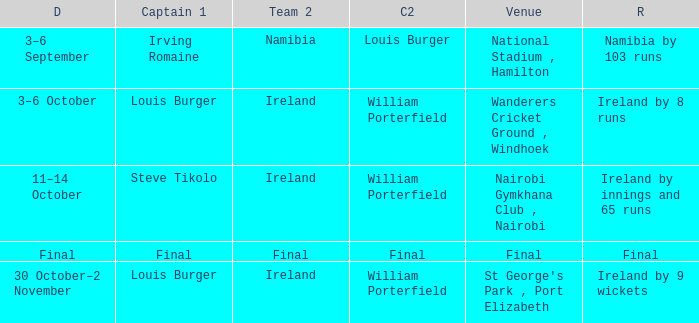Which Result has a Captain 2 of louis burger? Namibia by 103 runs. Can you parse all the data within this table? {'header': ['D', 'Captain 1', 'Team 2', 'C2', 'Venue', 'R'], 'rows': [['3–6 September', 'Irving Romaine', 'Namibia', 'Louis Burger', 'National Stadium , Hamilton', 'Namibia by 103 runs'], ['3–6 October', 'Louis Burger', 'Ireland', 'William Porterfield', 'Wanderers Cricket Ground , Windhoek', 'Ireland by 8 runs'], ['11–14 October', 'Steve Tikolo', 'Ireland', 'William Porterfield', 'Nairobi Gymkhana Club , Nairobi', 'Ireland by innings and 65 runs'], ['Final', 'Final', 'Final', 'Final', 'Final', 'Final'], ['30 October–2 November', 'Louis Burger', 'Ireland', 'William Porterfield', "St George's Park , Port Elizabeth", 'Ireland by 9 wickets']]} 